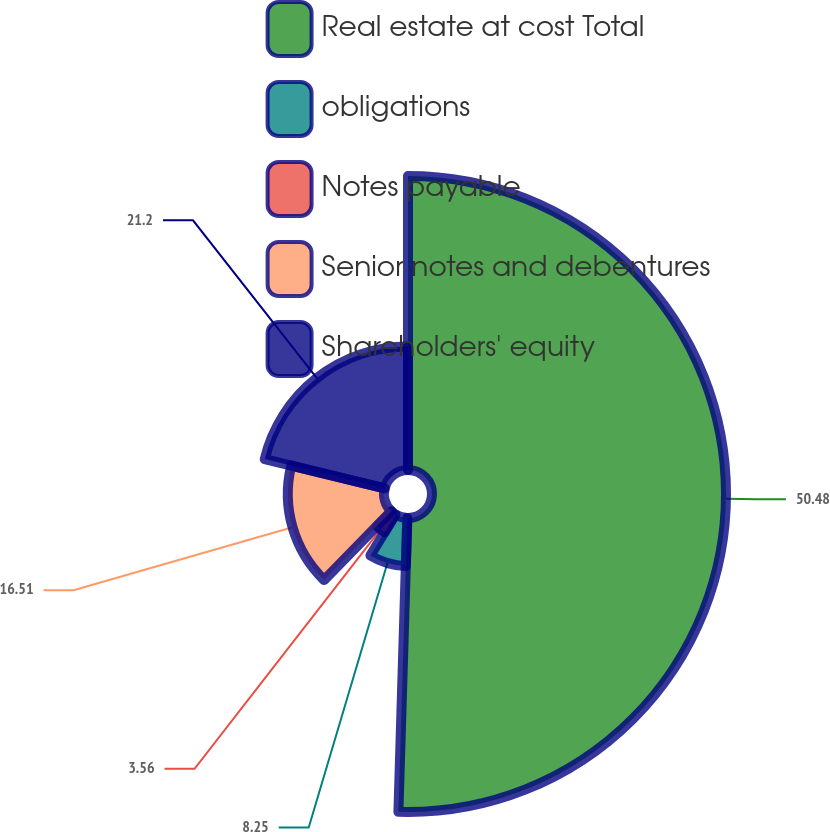Convert chart. <chart><loc_0><loc_0><loc_500><loc_500><pie_chart><fcel>Real estate at cost Total<fcel>obligations<fcel>Notes payable<fcel>Senior notes and debentures<fcel>Shareholders' equity<nl><fcel>50.48%<fcel>8.25%<fcel>3.56%<fcel>16.51%<fcel>21.2%<nl></chart> 